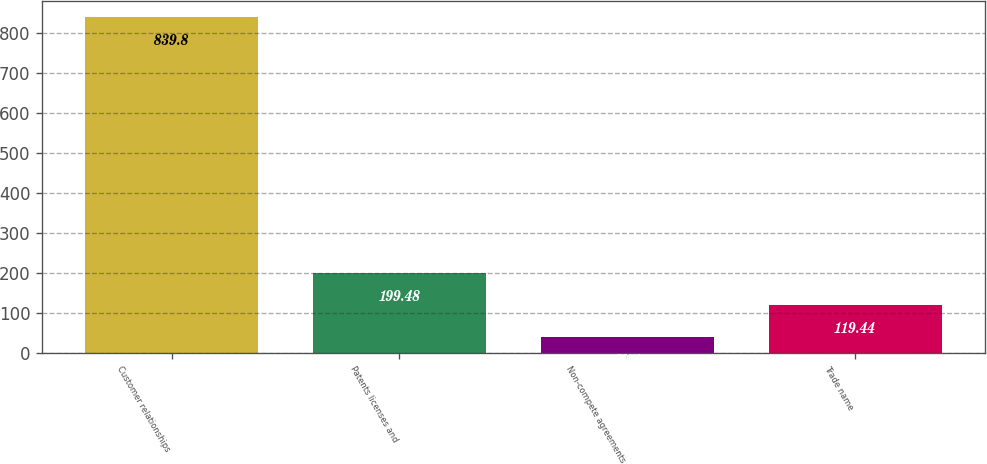Convert chart to OTSL. <chart><loc_0><loc_0><loc_500><loc_500><bar_chart><fcel>Customer relationships<fcel>Patents licenses and<fcel>Non-compete agreements<fcel>Trade name<nl><fcel>839.8<fcel>199.48<fcel>39.4<fcel>119.44<nl></chart> 